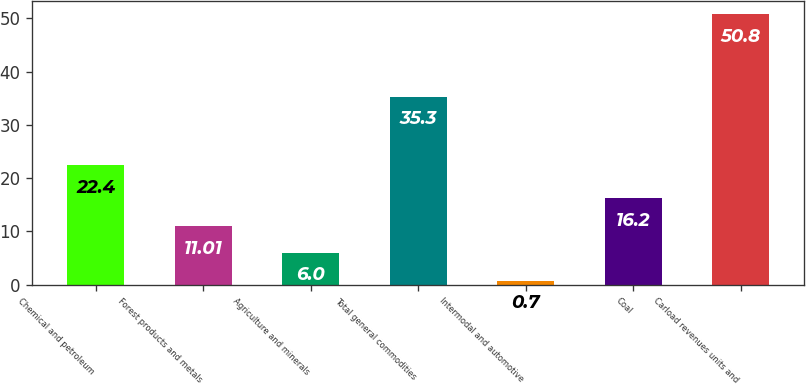Convert chart to OTSL. <chart><loc_0><loc_0><loc_500><loc_500><bar_chart><fcel>Chemical and petroleum<fcel>Forest products and metals<fcel>Agriculture and minerals<fcel>Total general commodities<fcel>Intermodal and automotive<fcel>Coal<fcel>Carload revenues units and<nl><fcel>22.4<fcel>11.01<fcel>6<fcel>35.3<fcel>0.7<fcel>16.2<fcel>50.8<nl></chart> 